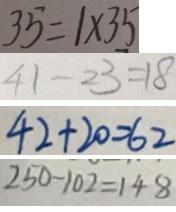Convert formula to latex. <formula><loc_0><loc_0><loc_500><loc_500>3 5 = 1 \times 3 5 
 4 1 - 2 3 = 1 8 
 4 2 + 2 0 = 6 2 
 2 5 0 - 1 0 2 = 1 4 8</formula> 